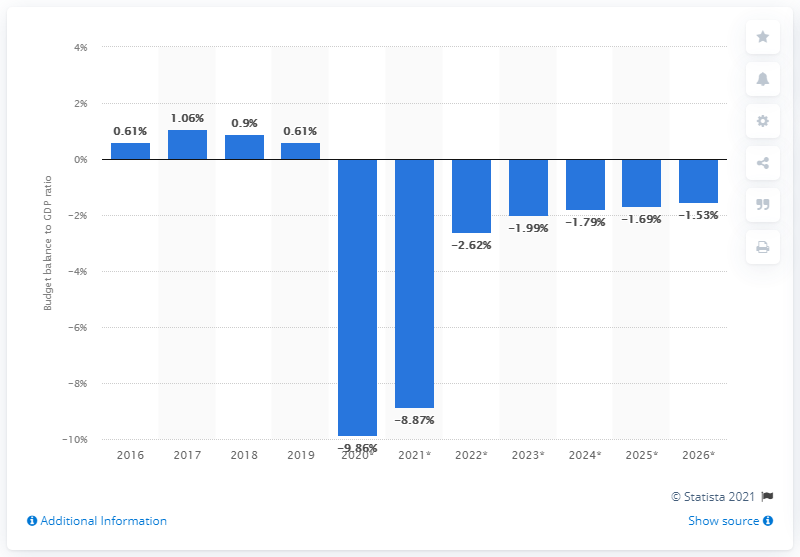Outline some significant characteristics in this image. In 2019, Greece's budget surplus accounted for 0.61% of the country's GDP. 